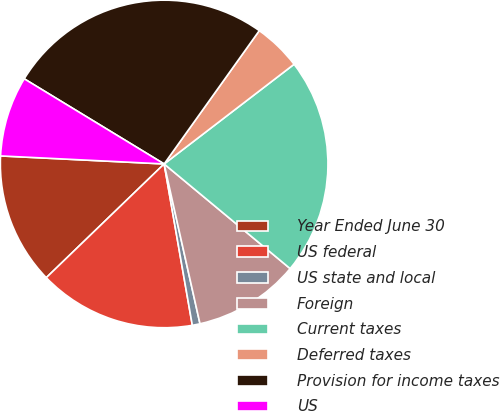Convert chart. <chart><loc_0><loc_0><loc_500><loc_500><pie_chart><fcel>Year Ended June 30<fcel>US federal<fcel>US state and local<fcel>Foreign<fcel>Current taxes<fcel>Deferred taxes<fcel>Provision for income taxes<fcel>US<nl><fcel>13.0%<fcel>15.54%<fcel>0.76%<fcel>10.46%<fcel>21.45%<fcel>4.72%<fcel>26.17%<fcel>7.92%<nl></chart> 